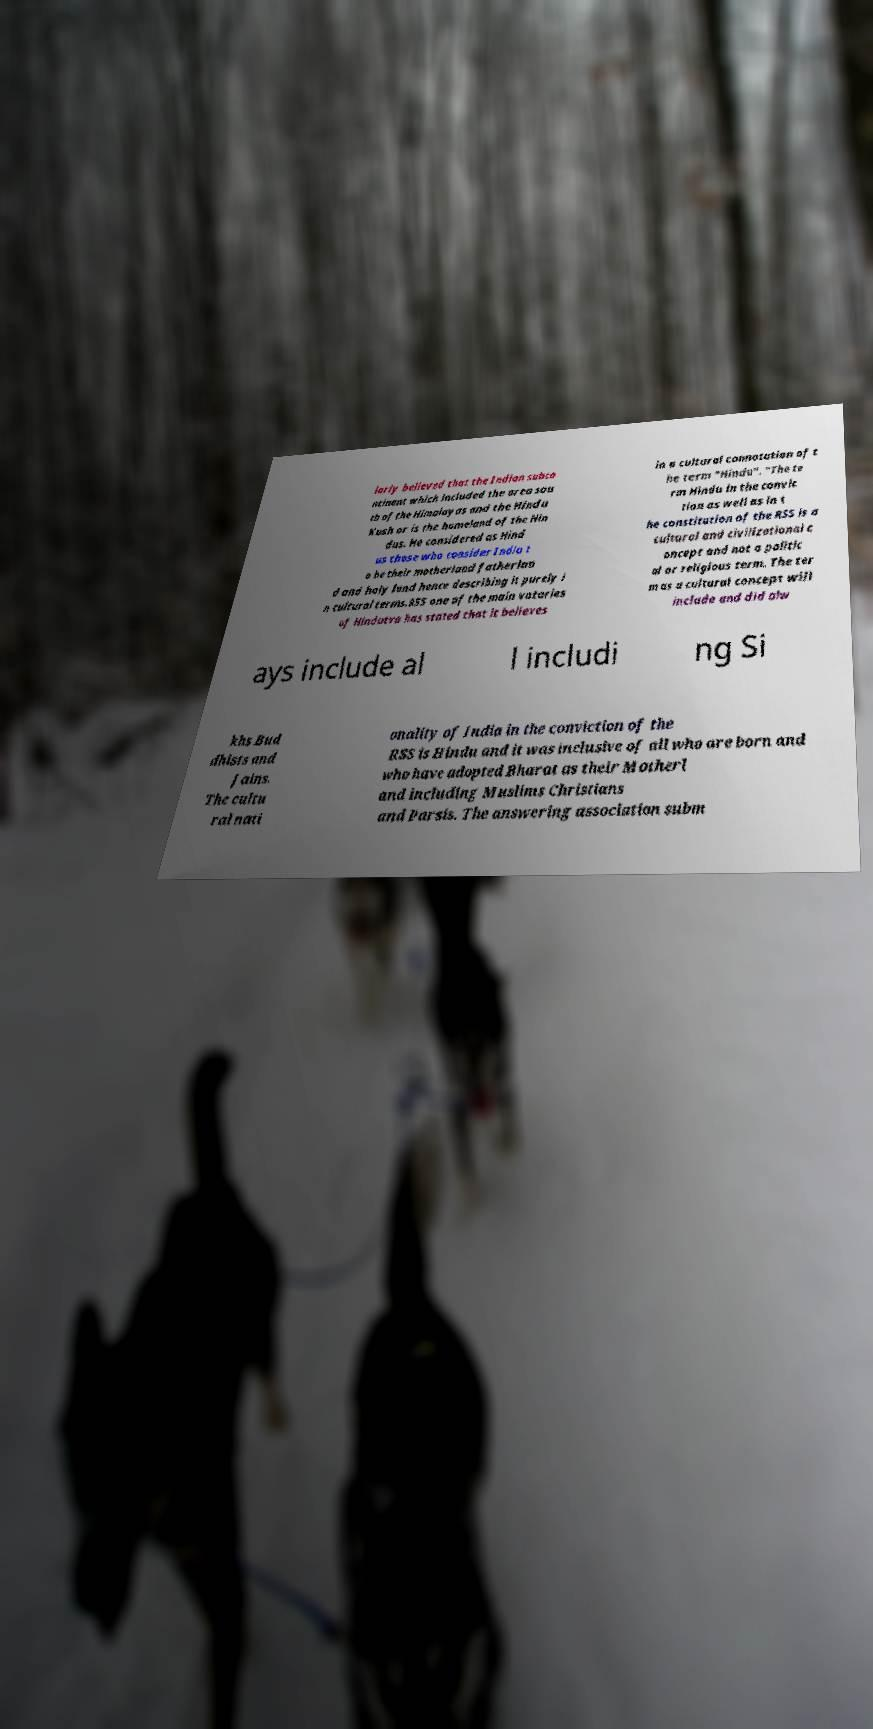I need the written content from this picture converted into text. Can you do that? larly believed that the Indian subco ntinent which included the area sou th of the Himalayas and the Hindu Kush or is the homeland of the Hin dus. He considered as Hind us those who consider India t o be their motherland fatherlan d and holy land hence describing it purely i n cultural terms.RSS one of the main votaries of Hindutva has stated that it believes in a cultural connotation of t he term "Hindu". "The te rm Hindu in the convic tion as well as in t he constitution of the RSS is a cultural and civilizational c oncept and not a politic al or religious term. The ter m as a cultural concept will include and did alw ays include al l includi ng Si khs Bud dhists and Jains. The cultu ral nati onality of India in the conviction of the RSS is Hindu and it was inclusive of all who are born and who have adopted Bharat as their Motherl and including Muslims Christians and Parsis. The answering association subm 